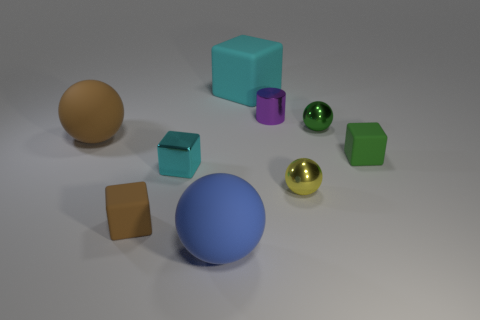Subtract 1 cubes. How many cubes are left? 3 Subtract all cyan spheres. Subtract all brown cylinders. How many spheres are left? 4 Add 1 large brown things. How many objects exist? 10 Subtract all cylinders. How many objects are left? 8 Subtract 1 green blocks. How many objects are left? 8 Subtract all green balls. Subtract all tiny red rubber cylinders. How many objects are left? 8 Add 9 small green matte objects. How many small green matte objects are left? 10 Add 4 tiny cylinders. How many tiny cylinders exist? 5 